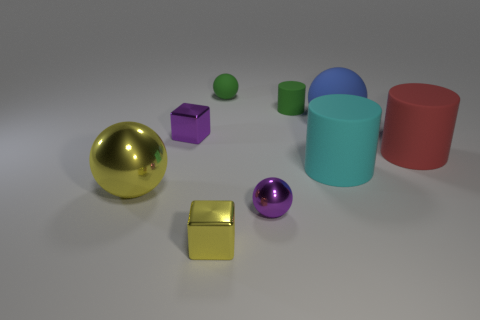Subtract all big cylinders. How many cylinders are left? 1 Subtract 2 cylinders. How many cylinders are left? 1 Subtract all spheres. How many objects are left? 5 Add 1 shiny things. How many objects exist? 10 Subtract all green cylinders. How many cylinders are left? 2 Subtract all red balls. Subtract all green cylinders. How many balls are left? 4 Subtract all red cubes. How many green balls are left? 1 Subtract all metal balls. Subtract all small purple cubes. How many objects are left? 6 Add 5 big rubber objects. How many big rubber objects are left? 8 Add 2 shiny blocks. How many shiny blocks exist? 4 